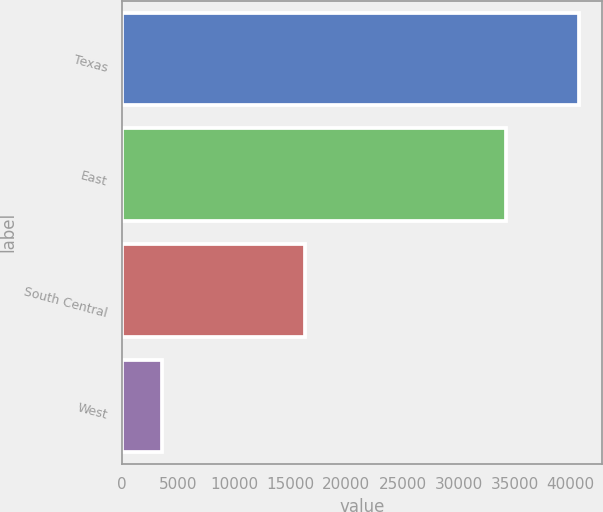Convert chart. <chart><loc_0><loc_0><loc_500><loc_500><bar_chart><fcel>Texas<fcel>East<fcel>South Central<fcel>West<nl><fcel>40734<fcel>34211<fcel>16329<fcel>3528<nl></chart> 